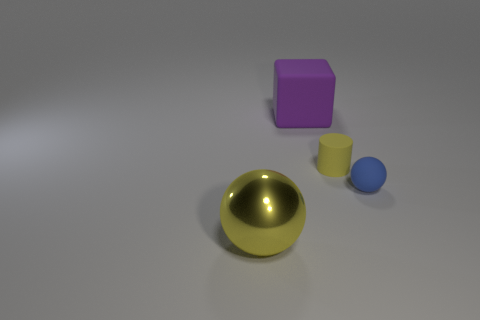Add 1 tiny cylinders. How many objects exist? 5 Add 1 tiny objects. How many tiny objects exist? 3 Subtract 0 green cylinders. How many objects are left? 4 Subtract all metallic spheres. Subtract all big blocks. How many objects are left? 2 Add 4 purple rubber cubes. How many purple rubber cubes are left? 5 